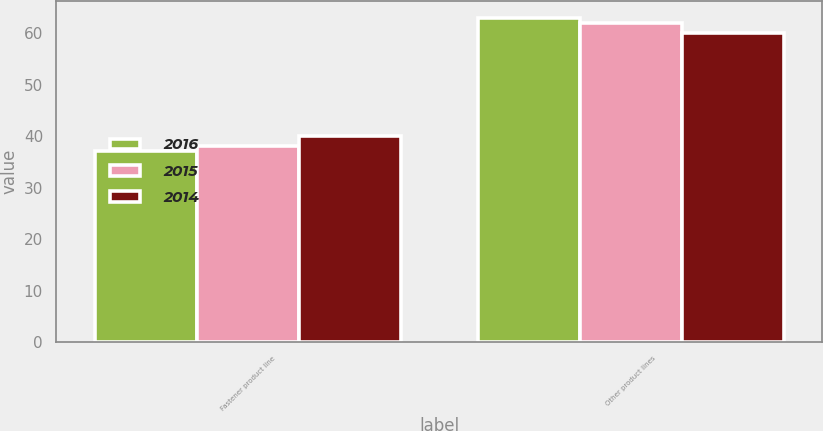Convert chart to OTSL. <chart><loc_0><loc_0><loc_500><loc_500><stacked_bar_chart><ecel><fcel>Fastener product line<fcel>Other product lines<nl><fcel>2016<fcel>37<fcel>63<nl><fcel>2015<fcel>38<fcel>62<nl><fcel>2014<fcel>40<fcel>60<nl></chart> 